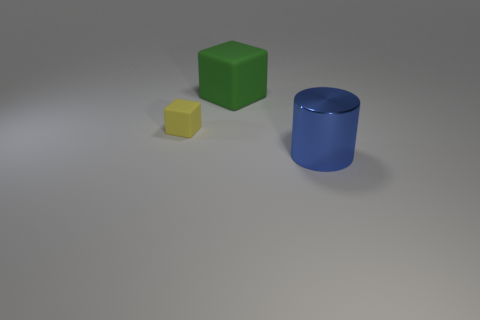Are there any other things that have the same material as the blue cylinder?
Give a very brief answer. No. Are any big cylinders visible?
Provide a succinct answer. Yes. Is the number of big matte things left of the small yellow rubber cube greater than the number of yellow cubes in front of the green matte thing?
Your answer should be compact. No. There is a thing that is both in front of the green matte thing and right of the yellow thing; what material is it?
Keep it short and to the point. Metal. Is the shape of the big blue thing the same as the tiny yellow object?
Provide a succinct answer. No. Is there anything else that has the same size as the yellow thing?
Offer a terse response. No. There is a yellow rubber block; what number of big shiny cylinders are to the left of it?
Your response must be concise. 0. Does the blue cylinder that is in front of the yellow block have the same size as the small yellow block?
Your response must be concise. No. There is another rubber object that is the same shape as the yellow thing; what is its color?
Provide a short and direct response. Green. Is there anything else that is the same shape as the metallic thing?
Make the answer very short. No. 